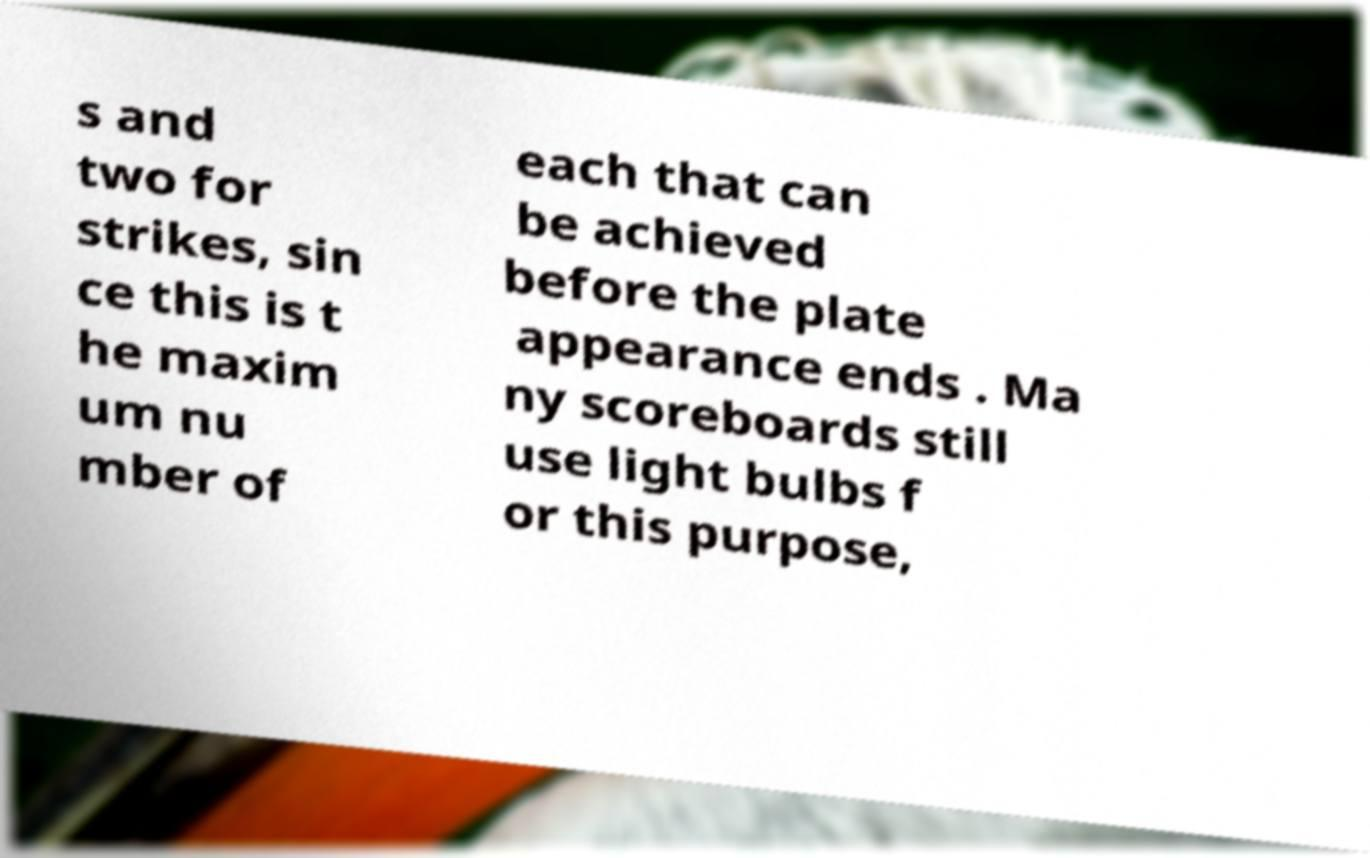Can you read and provide the text displayed in the image?This photo seems to have some interesting text. Can you extract and type it out for me? s and two for strikes, sin ce this is t he maxim um nu mber of each that can be achieved before the plate appearance ends . Ma ny scoreboards still use light bulbs f or this purpose, 